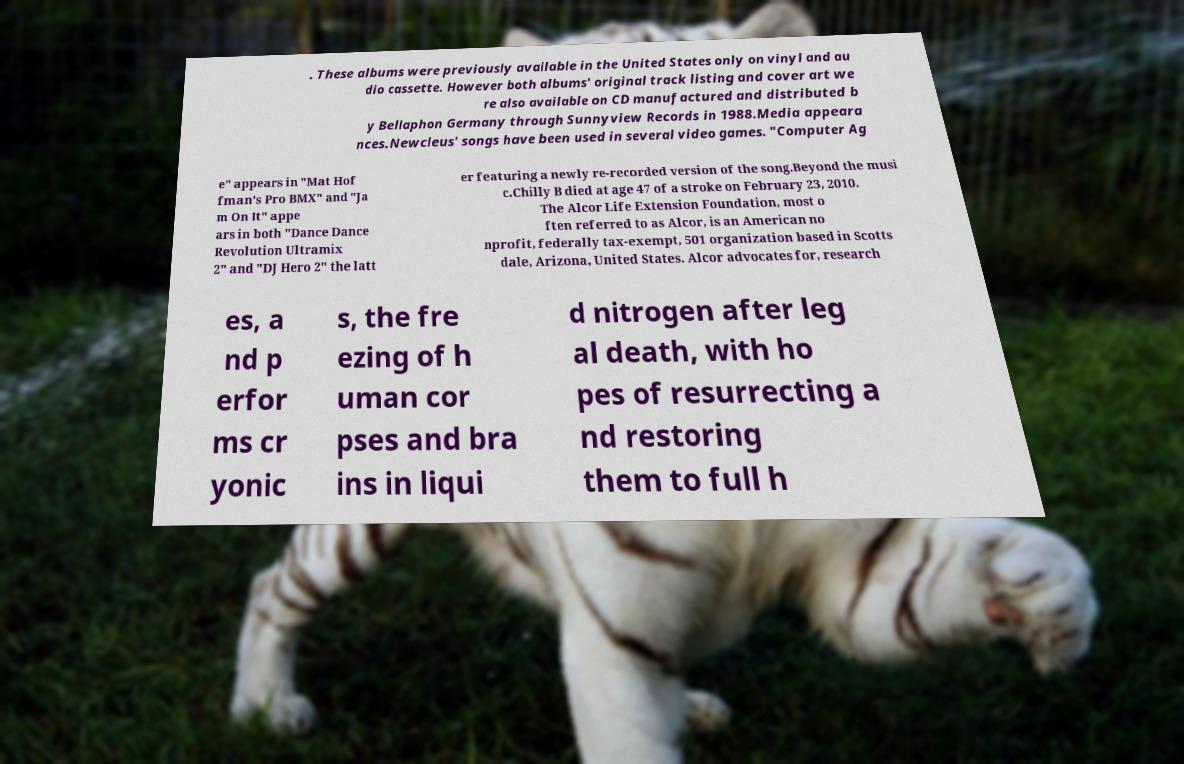Please read and relay the text visible in this image. What does it say? . These albums were previously available in the United States only on vinyl and au dio cassette. However both albums' original track listing and cover art we re also available on CD manufactured and distributed b y Bellaphon Germany through Sunnyview Records in 1988.Media appeara nces.Newcleus' songs have been used in several video games. "Computer Ag e" appears in "Mat Hof fman's Pro BMX" and "Ja m On It" appe ars in both "Dance Dance Revolution Ultramix 2" and "DJ Hero 2" the latt er featuring a newly re-recorded version of the song.Beyond the musi c.Chilly B died at age 47 of a stroke on February 23, 2010. The Alcor Life Extension Foundation, most o ften referred to as Alcor, is an American no nprofit, federally tax-exempt, 501 organization based in Scotts dale, Arizona, United States. Alcor advocates for, research es, a nd p erfor ms cr yonic s, the fre ezing of h uman cor pses and bra ins in liqui d nitrogen after leg al death, with ho pes of resurrecting a nd restoring them to full h 